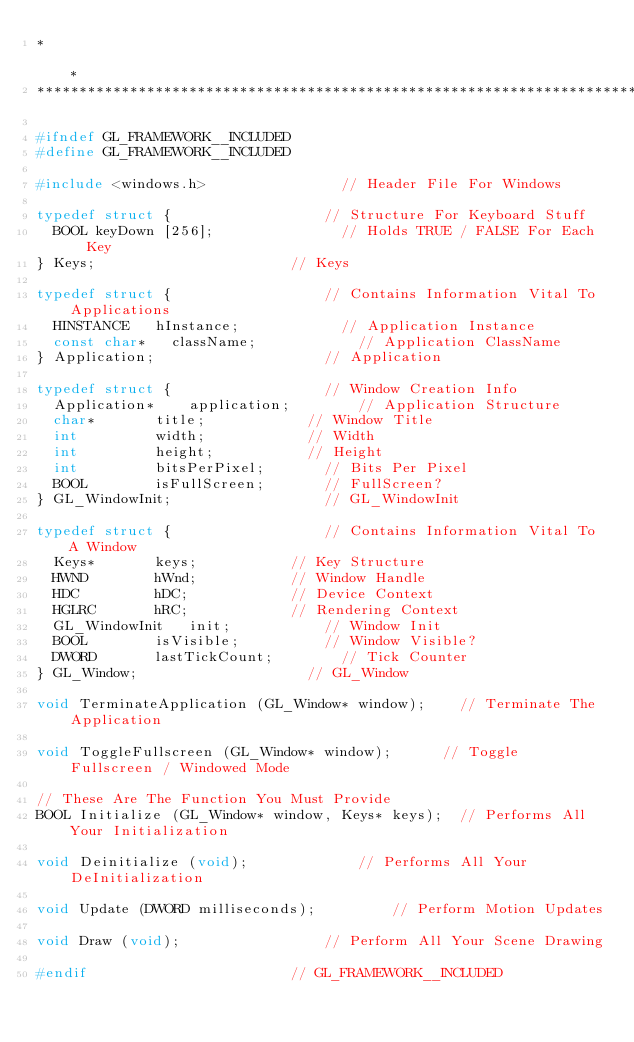<code> <loc_0><loc_0><loc_500><loc_500><_C_>*                                                                                *
*********************************************************************************/

#ifndef GL_FRAMEWORK__INCLUDED
#define GL_FRAMEWORK__INCLUDED

#include <windows.h>								// Header File For Windows

typedef struct {									// Structure For Keyboard Stuff
	BOOL keyDown [256];								// Holds TRUE / FALSE For Each Key
} Keys;												// Keys

typedef struct {									// Contains Information Vital To Applications
	HINSTANCE		hInstance;						// Application Instance
	const char*		className;						// Application ClassName
} Application;										// Application

typedef struct {									// Window Creation Info
	Application*		application;				// Application Structure
	char*				title;						// Window Title
	int					width;						// Width
	int					height;						// Height
	int					bitsPerPixel;				// Bits Per Pixel
	BOOL				isFullScreen;				// FullScreen?
} GL_WindowInit;									// GL_WindowInit

typedef struct {									// Contains Information Vital To A Window
	Keys*				keys;						// Key Structure
	HWND				hWnd;						// Window Handle
	HDC					hDC;						// Device Context
	HGLRC				hRC;						// Rendering Context
	GL_WindowInit		init;						// Window Init
	BOOL				isVisible;					// Window Visible?
	DWORD				lastTickCount;				// Tick Counter
} GL_Window;										// GL_Window

void TerminateApplication (GL_Window* window);		// Terminate The Application

void ToggleFullscreen (GL_Window* window);			// Toggle Fullscreen / Windowed Mode

// These Are The Function You Must Provide
BOOL Initialize (GL_Window* window, Keys* keys);	// Performs All Your Initialization

void Deinitialize (void);							// Performs All Your DeInitialization

void Update (DWORD milliseconds);					// Perform Motion Updates

void Draw (void);									// Perform All Your Scene Drawing

#endif												// GL_FRAMEWORK__INCLUDED
</code> 